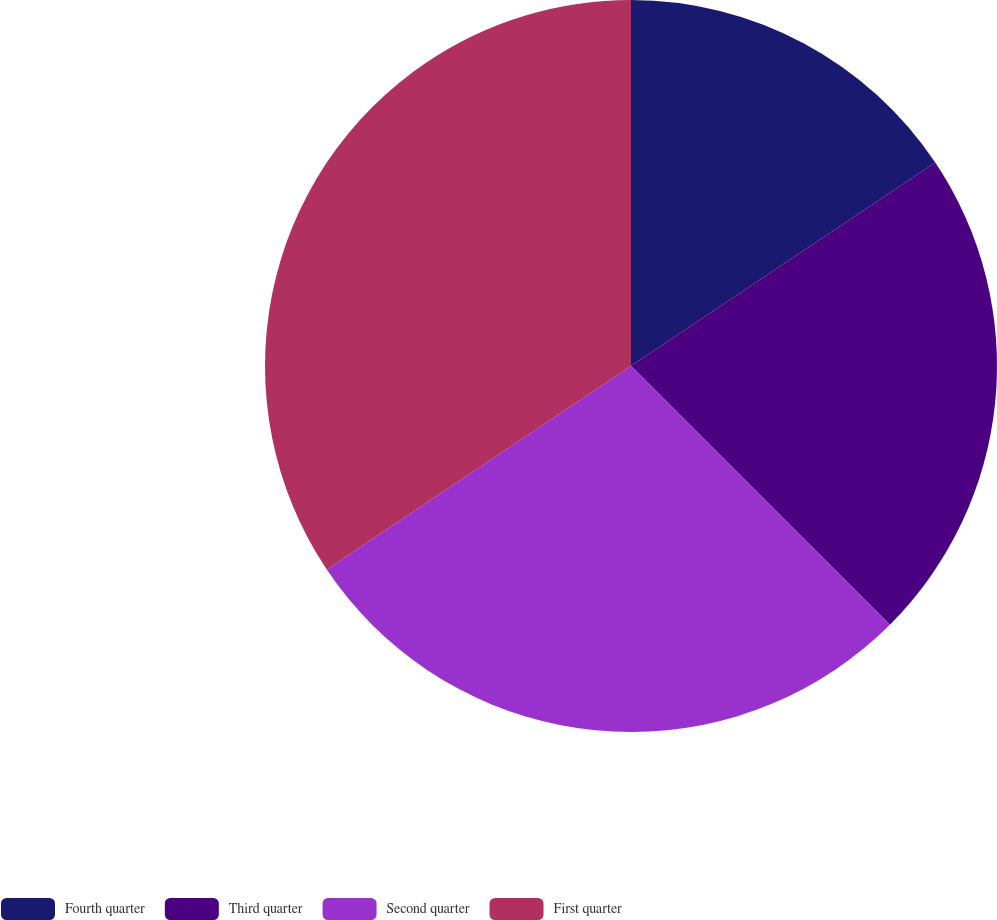Convert chart to OTSL. <chart><loc_0><loc_0><loc_500><loc_500><pie_chart><fcel>Fourth quarter<fcel>Third quarter<fcel>Second quarter<fcel>First quarter<nl><fcel>15.62%<fcel>21.87%<fcel>28.12%<fcel>34.38%<nl></chart> 